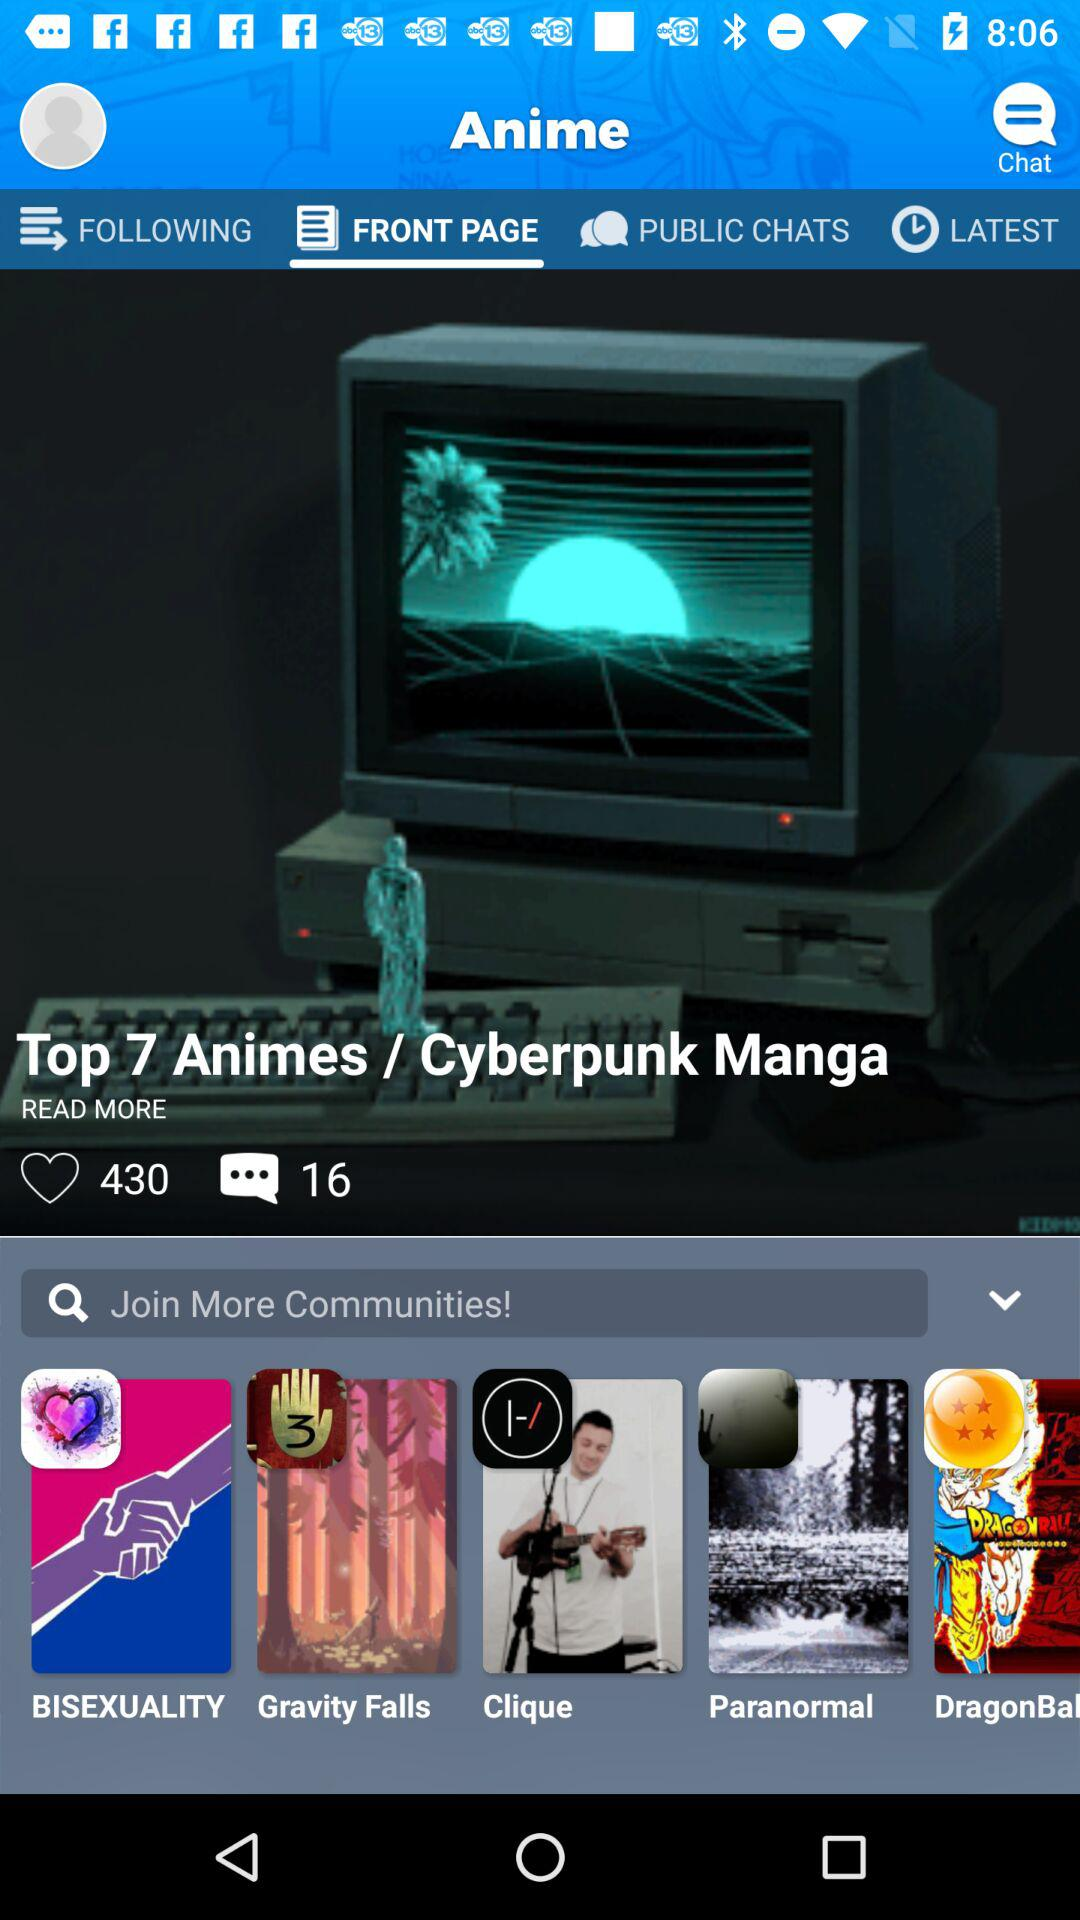How many comments are there? There are 16 comments. 